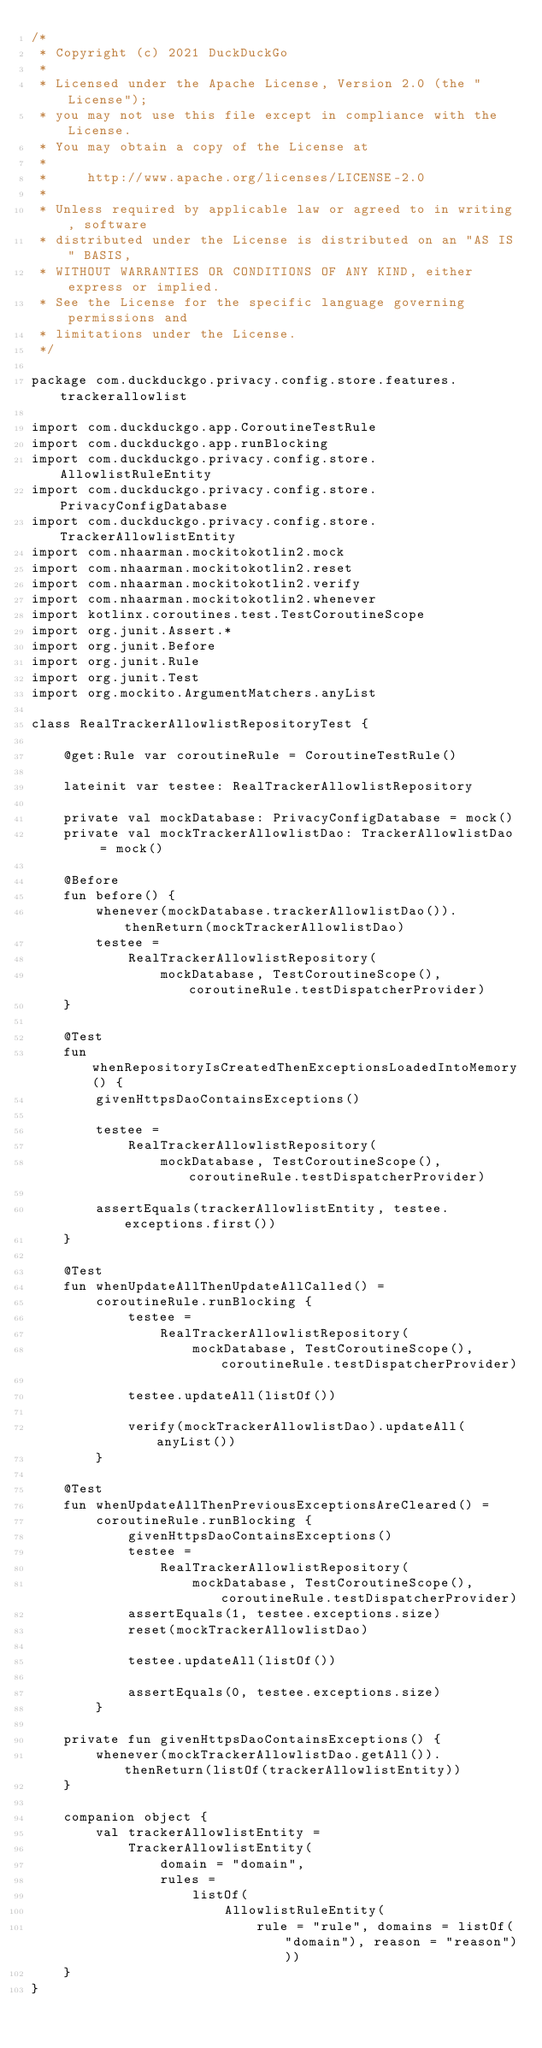<code> <loc_0><loc_0><loc_500><loc_500><_Kotlin_>/*
 * Copyright (c) 2021 DuckDuckGo
 *
 * Licensed under the Apache License, Version 2.0 (the "License");
 * you may not use this file except in compliance with the License.
 * You may obtain a copy of the License at
 *
 *     http://www.apache.org/licenses/LICENSE-2.0
 *
 * Unless required by applicable law or agreed to in writing, software
 * distributed under the License is distributed on an "AS IS" BASIS,
 * WITHOUT WARRANTIES OR CONDITIONS OF ANY KIND, either express or implied.
 * See the License for the specific language governing permissions and
 * limitations under the License.
 */

package com.duckduckgo.privacy.config.store.features.trackerallowlist

import com.duckduckgo.app.CoroutineTestRule
import com.duckduckgo.app.runBlocking
import com.duckduckgo.privacy.config.store.AllowlistRuleEntity
import com.duckduckgo.privacy.config.store.PrivacyConfigDatabase
import com.duckduckgo.privacy.config.store.TrackerAllowlistEntity
import com.nhaarman.mockitokotlin2.mock
import com.nhaarman.mockitokotlin2.reset
import com.nhaarman.mockitokotlin2.verify
import com.nhaarman.mockitokotlin2.whenever
import kotlinx.coroutines.test.TestCoroutineScope
import org.junit.Assert.*
import org.junit.Before
import org.junit.Rule
import org.junit.Test
import org.mockito.ArgumentMatchers.anyList

class RealTrackerAllowlistRepositoryTest {

    @get:Rule var coroutineRule = CoroutineTestRule()

    lateinit var testee: RealTrackerAllowlistRepository

    private val mockDatabase: PrivacyConfigDatabase = mock()
    private val mockTrackerAllowlistDao: TrackerAllowlistDao = mock()

    @Before
    fun before() {
        whenever(mockDatabase.trackerAllowlistDao()).thenReturn(mockTrackerAllowlistDao)
        testee =
            RealTrackerAllowlistRepository(
                mockDatabase, TestCoroutineScope(), coroutineRule.testDispatcherProvider)
    }

    @Test
    fun whenRepositoryIsCreatedThenExceptionsLoadedIntoMemory() {
        givenHttpsDaoContainsExceptions()

        testee =
            RealTrackerAllowlistRepository(
                mockDatabase, TestCoroutineScope(), coroutineRule.testDispatcherProvider)

        assertEquals(trackerAllowlistEntity, testee.exceptions.first())
    }

    @Test
    fun whenUpdateAllThenUpdateAllCalled() =
        coroutineRule.runBlocking {
            testee =
                RealTrackerAllowlistRepository(
                    mockDatabase, TestCoroutineScope(), coroutineRule.testDispatcherProvider)

            testee.updateAll(listOf())

            verify(mockTrackerAllowlistDao).updateAll(anyList())
        }

    @Test
    fun whenUpdateAllThenPreviousExceptionsAreCleared() =
        coroutineRule.runBlocking {
            givenHttpsDaoContainsExceptions()
            testee =
                RealTrackerAllowlistRepository(
                    mockDatabase, TestCoroutineScope(), coroutineRule.testDispatcherProvider)
            assertEquals(1, testee.exceptions.size)
            reset(mockTrackerAllowlistDao)

            testee.updateAll(listOf())

            assertEquals(0, testee.exceptions.size)
        }

    private fun givenHttpsDaoContainsExceptions() {
        whenever(mockTrackerAllowlistDao.getAll()).thenReturn(listOf(trackerAllowlistEntity))
    }

    companion object {
        val trackerAllowlistEntity =
            TrackerAllowlistEntity(
                domain = "domain",
                rules =
                    listOf(
                        AllowlistRuleEntity(
                            rule = "rule", domains = listOf("domain"), reason = "reason")))
    }
}
</code> 